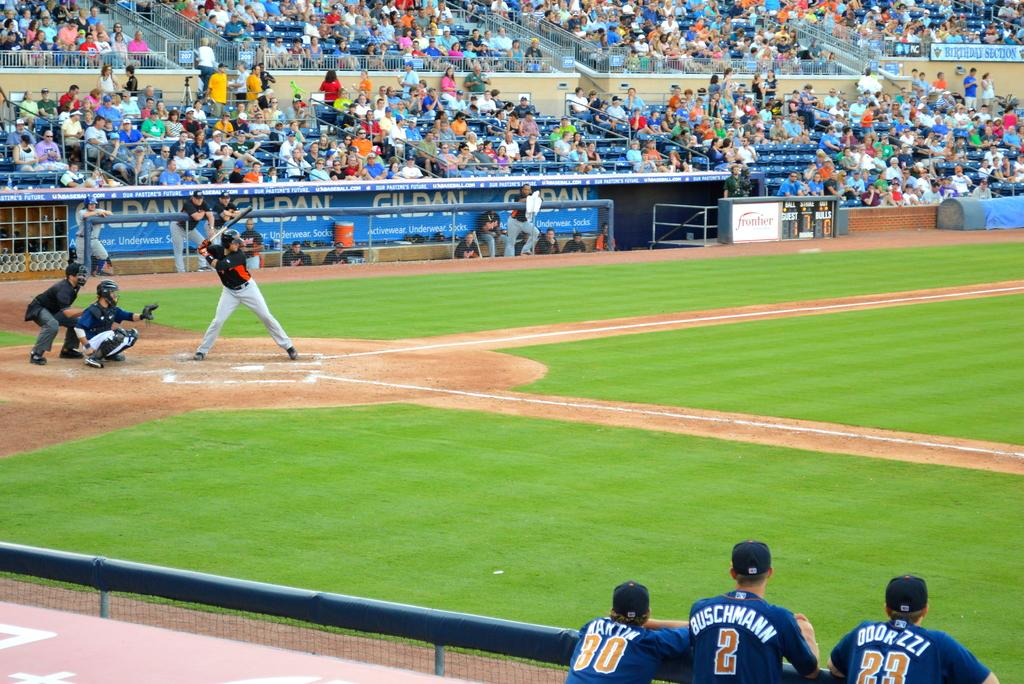Provide a one-sentence caption for the provided image. A baseball player in a number two uniform with the last name Buschmann stands at the fence and watches the game with two teammates. 